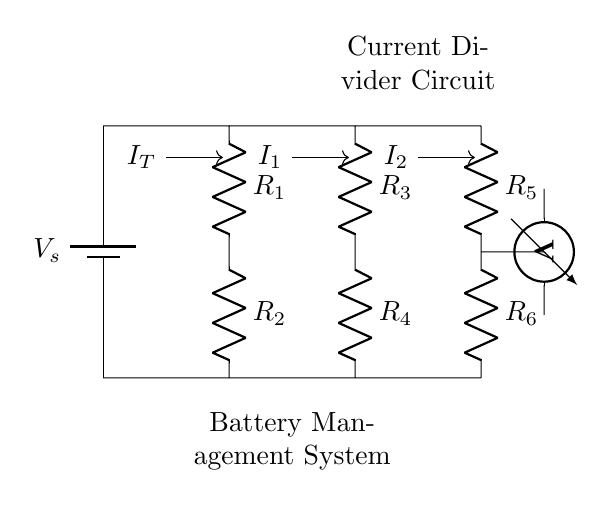What is the total current entering the circuit? The total current entering the circuit is labeled as I_T, which is displayed on the left side of the diagram.
Answer: I_T How many resistors are in the current divider branch? The diagram shows three resistors in the current divider branch, labeled as R_3, R_4, R_5, and R_6, which are connected in two parallel branches.
Answer: 3 What type of circuit is represented in the diagram? The circuit is a current divider circuit as indicated by the labels and the arrangement of resistors sharing the same voltage source.
Answer: Current Divider What is the resistance of the first resistor in the main current path? The first resistor in the main current path is labeled as R_1, and its resistance value can be seen in the circuit.
Answer: R_1 How do the resistors R_3 and R_4 compare in terms of current division? R_3 and R_4 are in parallel; thus, they divide the total current I_T based on their resistance values according to the current divider rule.
Answer: Depends on resistance What is the role of the voltmeter in this circuit? The voltmeter measures the voltage across the resistor R_6, which helps monitor the battery voltage or the voltage drop across a component.
Answer: Measure voltage What will happen to the current if R_5 is increased? If R_5 is increased, the total resistance in its branch increases, leading to a decrease in the current I_2 flowing through that branch.
Answer: Decrease in I_2 